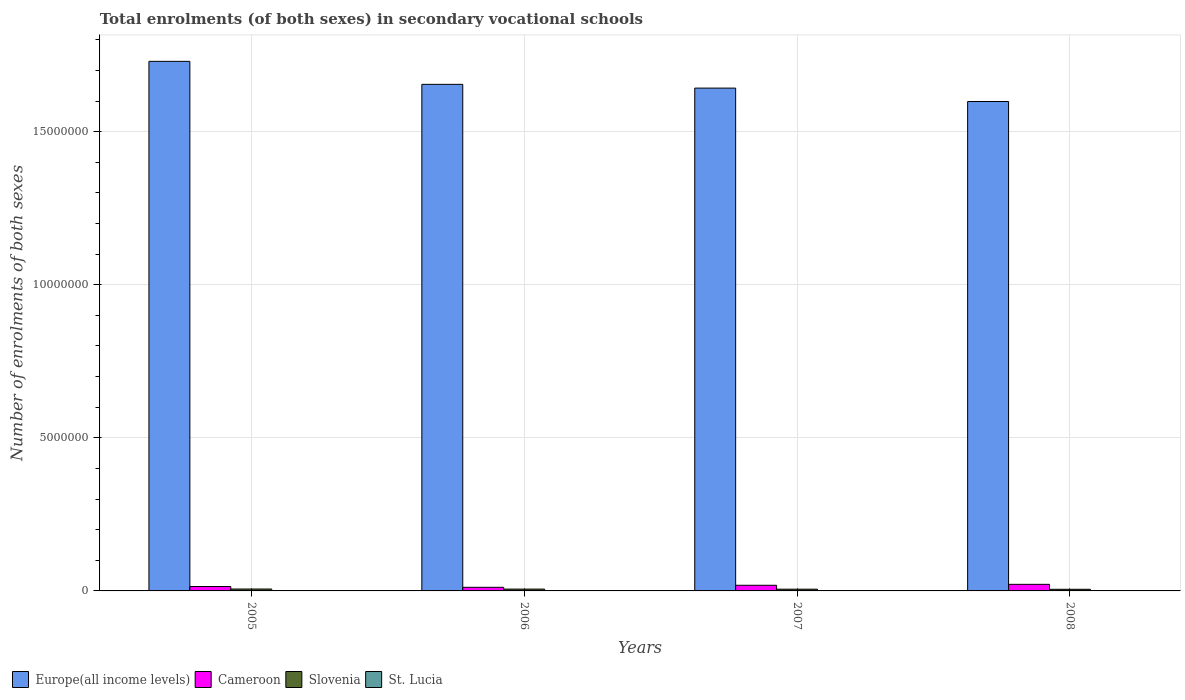How many groups of bars are there?
Provide a succinct answer. 4. Are the number of bars per tick equal to the number of legend labels?
Your answer should be very brief. Yes. Are the number of bars on each tick of the X-axis equal?
Offer a terse response. Yes. How many bars are there on the 4th tick from the right?
Keep it short and to the point. 4. What is the label of the 1st group of bars from the left?
Offer a terse response. 2005. In how many cases, is the number of bars for a given year not equal to the number of legend labels?
Provide a short and direct response. 0. What is the number of enrolments in secondary schools in Europe(all income levels) in 2008?
Your response must be concise. 1.60e+07. Across all years, what is the maximum number of enrolments in secondary schools in Cameroon?
Provide a succinct answer. 2.15e+05. Across all years, what is the minimum number of enrolments in secondary schools in Cameroon?
Give a very brief answer. 1.18e+05. What is the total number of enrolments in secondary schools in Europe(all income levels) in the graph?
Make the answer very short. 6.62e+07. What is the difference between the number of enrolments in secondary schools in Europe(all income levels) in 2007 and that in 2008?
Offer a terse response. 4.38e+05. What is the difference between the number of enrolments in secondary schools in Europe(all income levels) in 2007 and the number of enrolments in secondary schools in Slovenia in 2008?
Give a very brief answer. 1.64e+07. What is the average number of enrolments in secondary schools in Europe(all income levels) per year?
Ensure brevity in your answer.  1.66e+07. In the year 2007, what is the difference between the number of enrolments in secondary schools in Europe(all income levels) and number of enrolments in secondary schools in St. Lucia?
Offer a terse response. 1.64e+07. In how many years, is the number of enrolments in secondary schools in St. Lucia greater than 13000000?
Give a very brief answer. 0. What is the ratio of the number of enrolments in secondary schools in St. Lucia in 2006 to that in 2008?
Offer a very short reply. 2.51. Is the number of enrolments in secondary schools in Slovenia in 2006 less than that in 2007?
Provide a succinct answer. No. What is the difference between the highest and the second highest number of enrolments in secondary schools in St. Lucia?
Ensure brevity in your answer.  154. What is the difference between the highest and the lowest number of enrolments in secondary schools in Europe(all income levels)?
Give a very brief answer. 1.31e+06. In how many years, is the number of enrolments in secondary schools in Slovenia greater than the average number of enrolments in secondary schools in Slovenia taken over all years?
Provide a succinct answer. 2. Is it the case that in every year, the sum of the number of enrolments in secondary schools in Cameroon and number of enrolments in secondary schools in Europe(all income levels) is greater than the sum of number of enrolments in secondary schools in St. Lucia and number of enrolments in secondary schools in Slovenia?
Keep it short and to the point. Yes. What does the 3rd bar from the left in 2007 represents?
Keep it short and to the point. Slovenia. What does the 2nd bar from the right in 2005 represents?
Your answer should be very brief. Slovenia. Are all the bars in the graph horizontal?
Keep it short and to the point. No. How many years are there in the graph?
Your response must be concise. 4. What is the difference between two consecutive major ticks on the Y-axis?
Your response must be concise. 5.00e+06. Are the values on the major ticks of Y-axis written in scientific E-notation?
Provide a short and direct response. No. How many legend labels are there?
Offer a very short reply. 4. How are the legend labels stacked?
Make the answer very short. Horizontal. What is the title of the graph?
Your answer should be compact. Total enrolments (of both sexes) in secondary vocational schools. Does "Tanzania" appear as one of the legend labels in the graph?
Provide a short and direct response. No. What is the label or title of the X-axis?
Offer a terse response. Years. What is the label or title of the Y-axis?
Make the answer very short. Number of enrolments of both sexes. What is the Number of enrolments of both sexes in Europe(all income levels) in 2005?
Keep it short and to the point. 1.73e+07. What is the Number of enrolments of both sexes in Cameroon in 2005?
Your answer should be very brief. 1.44e+05. What is the Number of enrolments of both sexes in Slovenia in 2005?
Ensure brevity in your answer.  6.18e+04. What is the Number of enrolments of both sexes of St. Lucia in 2005?
Offer a terse response. 757. What is the Number of enrolments of both sexes of Europe(all income levels) in 2006?
Ensure brevity in your answer.  1.65e+07. What is the Number of enrolments of both sexes in Cameroon in 2006?
Your answer should be very brief. 1.18e+05. What is the Number of enrolments of both sexes in Slovenia in 2006?
Give a very brief answer. 5.96e+04. What is the Number of enrolments of both sexes in St. Lucia in 2006?
Give a very brief answer. 603. What is the Number of enrolments of both sexes of Europe(all income levels) in 2007?
Offer a very short reply. 1.64e+07. What is the Number of enrolments of both sexes in Cameroon in 2007?
Provide a succinct answer. 1.84e+05. What is the Number of enrolments of both sexes of Slovenia in 2007?
Ensure brevity in your answer.  5.67e+04. What is the Number of enrolments of both sexes in St. Lucia in 2007?
Provide a short and direct response. 284. What is the Number of enrolments of both sexes of Europe(all income levels) in 2008?
Your response must be concise. 1.60e+07. What is the Number of enrolments of both sexes of Cameroon in 2008?
Your answer should be very brief. 2.15e+05. What is the Number of enrolments of both sexes of Slovenia in 2008?
Your answer should be very brief. 5.36e+04. What is the Number of enrolments of both sexes of St. Lucia in 2008?
Offer a very short reply. 240. Across all years, what is the maximum Number of enrolments of both sexes of Europe(all income levels)?
Provide a short and direct response. 1.73e+07. Across all years, what is the maximum Number of enrolments of both sexes of Cameroon?
Offer a very short reply. 2.15e+05. Across all years, what is the maximum Number of enrolments of both sexes in Slovenia?
Provide a short and direct response. 6.18e+04. Across all years, what is the maximum Number of enrolments of both sexes of St. Lucia?
Your answer should be compact. 757. Across all years, what is the minimum Number of enrolments of both sexes of Europe(all income levels)?
Offer a terse response. 1.60e+07. Across all years, what is the minimum Number of enrolments of both sexes of Cameroon?
Give a very brief answer. 1.18e+05. Across all years, what is the minimum Number of enrolments of both sexes of Slovenia?
Provide a succinct answer. 5.36e+04. Across all years, what is the minimum Number of enrolments of both sexes in St. Lucia?
Provide a short and direct response. 240. What is the total Number of enrolments of both sexes of Europe(all income levels) in the graph?
Keep it short and to the point. 6.62e+07. What is the total Number of enrolments of both sexes of Cameroon in the graph?
Ensure brevity in your answer.  6.62e+05. What is the total Number of enrolments of both sexes in Slovenia in the graph?
Your response must be concise. 2.32e+05. What is the total Number of enrolments of both sexes in St. Lucia in the graph?
Your answer should be compact. 1884. What is the difference between the Number of enrolments of both sexes of Europe(all income levels) in 2005 and that in 2006?
Make the answer very short. 7.51e+05. What is the difference between the Number of enrolments of both sexes of Cameroon in 2005 and that in 2006?
Provide a succinct answer. 2.60e+04. What is the difference between the Number of enrolments of both sexes of Slovenia in 2005 and that in 2006?
Provide a succinct answer. 2196. What is the difference between the Number of enrolments of both sexes of St. Lucia in 2005 and that in 2006?
Provide a short and direct response. 154. What is the difference between the Number of enrolments of both sexes of Europe(all income levels) in 2005 and that in 2007?
Offer a terse response. 8.74e+05. What is the difference between the Number of enrolments of both sexes in Cameroon in 2005 and that in 2007?
Provide a succinct answer. -4.03e+04. What is the difference between the Number of enrolments of both sexes in Slovenia in 2005 and that in 2007?
Offer a very short reply. 5099. What is the difference between the Number of enrolments of both sexes in St. Lucia in 2005 and that in 2007?
Provide a succinct answer. 473. What is the difference between the Number of enrolments of both sexes in Europe(all income levels) in 2005 and that in 2008?
Your answer should be compact. 1.31e+06. What is the difference between the Number of enrolments of both sexes of Cameroon in 2005 and that in 2008?
Your response must be concise. -7.11e+04. What is the difference between the Number of enrolments of both sexes in Slovenia in 2005 and that in 2008?
Your answer should be compact. 8223. What is the difference between the Number of enrolments of both sexes of St. Lucia in 2005 and that in 2008?
Provide a short and direct response. 517. What is the difference between the Number of enrolments of both sexes in Europe(all income levels) in 2006 and that in 2007?
Ensure brevity in your answer.  1.23e+05. What is the difference between the Number of enrolments of both sexes of Cameroon in 2006 and that in 2007?
Make the answer very short. -6.64e+04. What is the difference between the Number of enrolments of both sexes in Slovenia in 2006 and that in 2007?
Your answer should be very brief. 2903. What is the difference between the Number of enrolments of both sexes in St. Lucia in 2006 and that in 2007?
Offer a terse response. 319. What is the difference between the Number of enrolments of both sexes of Europe(all income levels) in 2006 and that in 2008?
Keep it short and to the point. 5.60e+05. What is the difference between the Number of enrolments of both sexes of Cameroon in 2006 and that in 2008?
Give a very brief answer. -9.72e+04. What is the difference between the Number of enrolments of both sexes of Slovenia in 2006 and that in 2008?
Provide a succinct answer. 6027. What is the difference between the Number of enrolments of both sexes in St. Lucia in 2006 and that in 2008?
Offer a terse response. 363. What is the difference between the Number of enrolments of both sexes in Europe(all income levels) in 2007 and that in 2008?
Provide a short and direct response. 4.38e+05. What is the difference between the Number of enrolments of both sexes in Cameroon in 2007 and that in 2008?
Offer a very short reply. -3.08e+04. What is the difference between the Number of enrolments of both sexes of Slovenia in 2007 and that in 2008?
Keep it short and to the point. 3124. What is the difference between the Number of enrolments of both sexes of Europe(all income levels) in 2005 and the Number of enrolments of both sexes of Cameroon in 2006?
Your response must be concise. 1.72e+07. What is the difference between the Number of enrolments of both sexes of Europe(all income levels) in 2005 and the Number of enrolments of both sexes of Slovenia in 2006?
Offer a terse response. 1.72e+07. What is the difference between the Number of enrolments of both sexes of Europe(all income levels) in 2005 and the Number of enrolments of both sexes of St. Lucia in 2006?
Offer a very short reply. 1.73e+07. What is the difference between the Number of enrolments of both sexes in Cameroon in 2005 and the Number of enrolments of both sexes in Slovenia in 2006?
Keep it short and to the point. 8.45e+04. What is the difference between the Number of enrolments of both sexes in Cameroon in 2005 and the Number of enrolments of both sexes in St. Lucia in 2006?
Provide a short and direct response. 1.43e+05. What is the difference between the Number of enrolments of both sexes of Slovenia in 2005 and the Number of enrolments of both sexes of St. Lucia in 2006?
Ensure brevity in your answer.  6.12e+04. What is the difference between the Number of enrolments of both sexes of Europe(all income levels) in 2005 and the Number of enrolments of both sexes of Cameroon in 2007?
Your answer should be compact. 1.71e+07. What is the difference between the Number of enrolments of both sexes in Europe(all income levels) in 2005 and the Number of enrolments of both sexes in Slovenia in 2007?
Your response must be concise. 1.72e+07. What is the difference between the Number of enrolments of both sexes of Europe(all income levels) in 2005 and the Number of enrolments of both sexes of St. Lucia in 2007?
Offer a very short reply. 1.73e+07. What is the difference between the Number of enrolments of both sexes of Cameroon in 2005 and the Number of enrolments of both sexes of Slovenia in 2007?
Provide a succinct answer. 8.74e+04. What is the difference between the Number of enrolments of both sexes in Cameroon in 2005 and the Number of enrolments of both sexes in St. Lucia in 2007?
Offer a very short reply. 1.44e+05. What is the difference between the Number of enrolments of both sexes of Slovenia in 2005 and the Number of enrolments of both sexes of St. Lucia in 2007?
Make the answer very short. 6.15e+04. What is the difference between the Number of enrolments of both sexes in Europe(all income levels) in 2005 and the Number of enrolments of both sexes in Cameroon in 2008?
Offer a terse response. 1.71e+07. What is the difference between the Number of enrolments of both sexes of Europe(all income levels) in 2005 and the Number of enrolments of both sexes of Slovenia in 2008?
Keep it short and to the point. 1.72e+07. What is the difference between the Number of enrolments of both sexes in Europe(all income levels) in 2005 and the Number of enrolments of both sexes in St. Lucia in 2008?
Your response must be concise. 1.73e+07. What is the difference between the Number of enrolments of both sexes of Cameroon in 2005 and the Number of enrolments of both sexes of Slovenia in 2008?
Your answer should be very brief. 9.05e+04. What is the difference between the Number of enrolments of both sexes in Cameroon in 2005 and the Number of enrolments of both sexes in St. Lucia in 2008?
Give a very brief answer. 1.44e+05. What is the difference between the Number of enrolments of both sexes in Slovenia in 2005 and the Number of enrolments of both sexes in St. Lucia in 2008?
Your answer should be very brief. 6.15e+04. What is the difference between the Number of enrolments of both sexes in Europe(all income levels) in 2006 and the Number of enrolments of both sexes in Cameroon in 2007?
Offer a very short reply. 1.64e+07. What is the difference between the Number of enrolments of both sexes of Europe(all income levels) in 2006 and the Number of enrolments of both sexes of Slovenia in 2007?
Offer a very short reply. 1.65e+07. What is the difference between the Number of enrolments of both sexes of Europe(all income levels) in 2006 and the Number of enrolments of both sexes of St. Lucia in 2007?
Your response must be concise. 1.65e+07. What is the difference between the Number of enrolments of both sexes in Cameroon in 2006 and the Number of enrolments of both sexes in Slovenia in 2007?
Offer a very short reply. 6.14e+04. What is the difference between the Number of enrolments of both sexes in Cameroon in 2006 and the Number of enrolments of both sexes in St. Lucia in 2007?
Your answer should be compact. 1.18e+05. What is the difference between the Number of enrolments of both sexes of Slovenia in 2006 and the Number of enrolments of both sexes of St. Lucia in 2007?
Make the answer very short. 5.93e+04. What is the difference between the Number of enrolments of both sexes in Europe(all income levels) in 2006 and the Number of enrolments of both sexes in Cameroon in 2008?
Provide a short and direct response. 1.63e+07. What is the difference between the Number of enrolments of both sexes in Europe(all income levels) in 2006 and the Number of enrolments of both sexes in Slovenia in 2008?
Offer a very short reply. 1.65e+07. What is the difference between the Number of enrolments of both sexes in Europe(all income levels) in 2006 and the Number of enrolments of both sexes in St. Lucia in 2008?
Keep it short and to the point. 1.65e+07. What is the difference between the Number of enrolments of both sexes in Cameroon in 2006 and the Number of enrolments of both sexes in Slovenia in 2008?
Offer a very short reply. 6.45e+04. What is the difference between the Number of enrolments of both sexes in Cameroon in 2006 and the Number of enrolments of both sexes in St. Lucia in 2008?
Ensure brevity in your answer.  1.18e+05. What is the difference between the Number of enrolments of both sexes in Slovenia in 2006 and the Number of enrolments of both sexes in St. Lucia in 2008?
Give a very brief answer. 5.94e+04. What is the difference between the Number of enrolments of both sexes in Europe(all income levels) in 2007 and the Number of enrolments of both sexes in Cameroon in 2008?
Keep it short and to the point. 1.62e+07. What is the difference between the Number of enrolments of both sexes in Europe(all income levels) in 2007 and the Number of enrolments of both sexes in Slovenia in 2008?
Provide a succinct answer. 1.64e+07. What is the difference between the Number of enrolments of both sexes of Europe(all income levels) in 2007 and the Number of enrolments of both sexes of St. Lucia in 2008?
Your response must be concise. 1.64e+07. What is the difference between the Number of enrolments of both sexes of Cameroon in 2007 and the Number of enrolments of both sexes of Slovenia in 2008?
Ensure brevity in your answer.  1.31e+05. What is the difference between the Number of enrolments of both sexes in Cameroon in 2007 and the Number of enrolments of both sexes in St. Lucia in 2008?
Your response must be concise. 1.84e+05. What is the difference between the Number of enrolments of both sexes in Slovenia in 2007 and the Number of enrolments of both sexes in St. Lucia in 2008?
Make the answer very short. 5.64e+04. What is the average Number of enrolments of both sexes of Europe(all income levels) per year?
Provide a short and direct response. 1.66e+07. What is the average Number of enrolments of both sexes of Cameroon per year?
Your answer should be compact. 1.65e+05. What is the average Number of enrolments of both sexes in Slovenia per year?
Your response must be concise. 5.79e+04. What is the average Number of enrolments of both sexes of St. Lucia per year?
Give a very brief answer. 471. In the year 2005, what is the difference between the Number of enrolments of both sexes of Europe(all income levels) and Number of enrolments of both sexes of Cameroon?
Make the answer very short. 1.72e+07. In the year 2005, what is the difference between the Number of enrolments of both sexes of Europe(all income levels) and Number of enrolments of both sexes of Slovenia?
Provide a short and direct response. 1.72e+07. In the year 2005, what is the difference between the Number of enrolments of both sexes of Europe(all income levels) and Number of enrolments of both sexes of St. Lucia?
Keep it short and to the point. 1.73e+07. In the year 2005, what is the difference between the Number of enrolments of both sexes of Cameroon and Number of enrolments of both sexes of Slovenia?
Your answer should be compact. 8.23e+04. In the year 2005, what is the difference between the Number of enrolments of both sexes of Cameroon and Number of enrolments of both sexes of St. Lucia?
Make the answer very short. 1.43e+05. In the year 2005, what is the difference between the Number of enrolments of both sexes in Slovenia and Number of enrolments of both sexes in St. Lucia?
Offer a terse response. 6.10e+04. In the year 2006, what is the difference between the Number of enrolments of both sexes in Europe(all income levels) and Number of enrolments of both sexes in Cameroon?
Your answer should be compact. 1.64e+07. In the year 2006, what is the difference between the Number of enrolments of both sexes in Europe(all income levels) and Number of enrolments of both sexes in Slovenia?
Make the answer very short. 1.65e+07. In the year 2006, what is the difference between the Number of enrolments of both sexes in Europe(all income levels) and Number of enrolments of both sexes in St. Lucia?
Your response must be concise. 1.65e+07. In the year 2006, what is the difference between the Number of enrolments of both sexes of Cameroon and Number of enrolments of both sexes of Slovenia?
Offer a very short reply. 5.84e+04. In the year 2006, what is the difference between the Number of enrolments of both sexes in Cameroon and Number of enrolments of both sexes in St. Lucia?
Your answer should be very brief. 1.17e+05. In the year 2006, what is the difference between the Number of enrolments of both sexes in Slovenia and Number of enrolments of both sexes in St. Lucia?
Offer a very short reply. 5.90e+04. In the year 2007, what is the difference between the Number of enrolments of both sexes of Europe(all income levels) and Number of enrolments of both sexes of Cameroon?
Provide a succinct answer. 1.62e+07. In the year 2007, what is the difference between the Number of enrolments of both sexes in Europe(all income levels) and Number of enrolments of both sexes in Slovenia?
Ensure brevity in your answer.  1.64e+07. In the year 2007, what is the difference between the Number of enrolments of both sexes in Europe(all income levels) and Number of enrolments of both sexes in St. Lucia?
Make the answer very short. 1.64e+07. In the year 2007, what is the difference between the Number of enrolments of both sexes of Cameroon and Number of enrolments of both sexes of Slovenia?
Ensure brevity in your answer.  1.28e+05. In the year 2007, what is the difference between the Number of enrolments of both sexes in Cameroon and Number of enrolments of both sexes in St. Lucia?
Offer a very short reply. 1.84e+05. In the year 2007, what is the difference between the Number of enrolments of both sexes of Slovenia and Number of enrolments of both sexes of St. Lucia?
Your response must be concise. 5.64e+04. In the year 2008, what is the difference between the Number of enrolments of both sexes in Europe(all income levels) and Number of enrolments of both sexes in Cameroon?
Make the answer very short. 1.58e+07. In the year 2008, what is the difference between the Number of enrolments of both sexes of Europe(all income levels) and Number of enrolments of both sexes of Slovenia?
Ensure brevity in your answer.  1.59e+07. In the year 2008, what is the difference between the Number of enrolments of both sexes of Europe(all income levels) and Number of enrolments of both sexes of St. Lucia?
Your response must be concise. 1.60e+07. In the year 2008, what is the difference between the Number of enrolments of both sexes of Cameroon and Number of enrolments of both sexes of Slovenia?
Your response must be concise. 1.62e+05. In the year 2008, what is the difference between the Number of enrolments of both sexes in Cameroon and Number of enrolments of both sexes in St. Lucia?
Offer a terse response. 2.15e+05. In the year 2008, what is the difference between the Number of enrolments of both sexes of Slovenia and Number of enrolments of both sexes of St. Lucia?
Make the answer very short. 5.33e+04. What is the ratio of the Number of enrolments of both sexes in Europe(all income levels) in 2005 to that in 2006?
Give a very brief answer. 1.05. What is the ratio of the Number of enrolments of both sexes in Cameroon in 2005 to that in 2006?
Offer a very short reply. 1.22. What is the ratio of the Number of enrolments of both sexes in Slovenia in 2005 to that in 2006?
Ensure brevity in your answer.  1.04. What is the ratio of the Number of enrolments of both sexes in St. Lucia in 2005 to that in 2006?
Keep it short and to the point. 1.26. What is the ratio of the Number of enrolments of both sexes in Europe(all income levels) in 2005 to that in 2007?
Offer a very short reply. 1.05. What is the ratio of the Number of enrolments of both sexes of Cameroon in 2005 to that in 2007?
Ensure brevity in your answer.  0.78. What is the ratio of the Number of enrolments of both sexes in Slovenia in 2005 to that in 2007?
Provide a short and direct response. 1.09. What is the ratio of the Number of enrolments of both sexes of St. Lucia in 2005 to that in 2007?
Keep it short and to the point. 2.67. What is the ratio of the Number of enrolments of both sexes of Europe(all income levels) in 2005 to that in 2008?
Your answer should be very brief. 1.08. What is the ratio of the Number of enrolments of both sexes of Cameroon in 2005 to that in 2008?
Ensure brevity in your answer.  0.67. What is the ratio of the Number of enrolments of both sexes in Slovenia in 2005 to that in 2008?
Offer a terse response. 1.15. What is the ratio of the Number of enrolments of both sexes in St. Lucia in 2005 to that in 2008?
Ensure brevity in your answer.  3.15. What is the ratio of the Number of enrolments of both sexes in Europe(all income levels) in 2006 to that in 2007?
Provide a short and direct response. 1.01. What is the ratio of the Number of enrolments of both sexes in Cameroon in 2006 to that in 2007?
Provide a succinct answer. 0.64. What is the ratio of the Number of enrolments of both sexes of Slovenia in 2006 to that in 2007?
Keep it short and to the point. 1.05. What is the ratio of the Number of enrolments of both sexes in St. Lucia in 2006 to that in 2007?
Keep it short and to the point. 2.12. What is the ratio of the Number of enrolments of both sexes in Europe(all income levels) in 2006 to that in 2008?
Your response must be concise. 1.04. What is the ratio of the Number of enrolments of both sexes in Cameroon in 2006 to that in 2008?
Keep it short and to the point. 0.55. What is the ratio of the Number of enrolments of both sexes of Slovenia in 2006 to that in 2008?
Make the answer very short. 1.11. What is the ratio of the Number of enrolments of both sexes of St. Lucia in 2006 to that in 2008?
Your answer should be very brief. 2.51. What is the ratio of the Number of enrolments of both sexes of Europe(all income levels) in 2007 to that in 2008?
Your answer should be very brief. 1.03. What is the ratio of the Number of enrolments of both sexes of Cameroon in 2007 to that in 2008?
Provide a short and direct response. 0.86. What is the ratio of the Number of enrolments of both sexes of Slovenia in 2007 to that in 2008?
Offer a terse response. 1.06. What is the ratio of the Number of enrolments of both sexes of St. Lucia in 2007 to that in 2008?
Offer a terse response. 1.18. What is the difference between the highest and the second highest Number of enrolments of both sexes of Europe(all income levels)?
Offer a terse response. 7.51e+05. What is the difference between the highest and the second highest Number of enrolments of both sexes in Cameroon?
Your answer should be very brief. 3.08e+04. What is the difference between the highest and the second highest Number of enrolments of both sexes in Slovenia?
Provide a succinct answer. 2196. What is the difference between the highest and the second highest Number of enrolments of both sexes of St. Lucia?
Ensure brevity in your answer.  154. What is the difference between the highest and the lowest Number of enrolments of both sexes of Europe(all income levels)?
Your response must be concise. 1.31e+06. What is the difference between the highest and the lowest Number of enrolments of both sexes in Cameroon?
Offer a terse response. 9.72e+04. What is the difference between the highest and the lowest Number of enrolments of both sexes in Slovenia?
Ensure brevity in your answer.  8223. What is the difference between the highest and the lowest Number of enrolments of both sexes in St. Lucia?
Your answer should be compact. 517. 